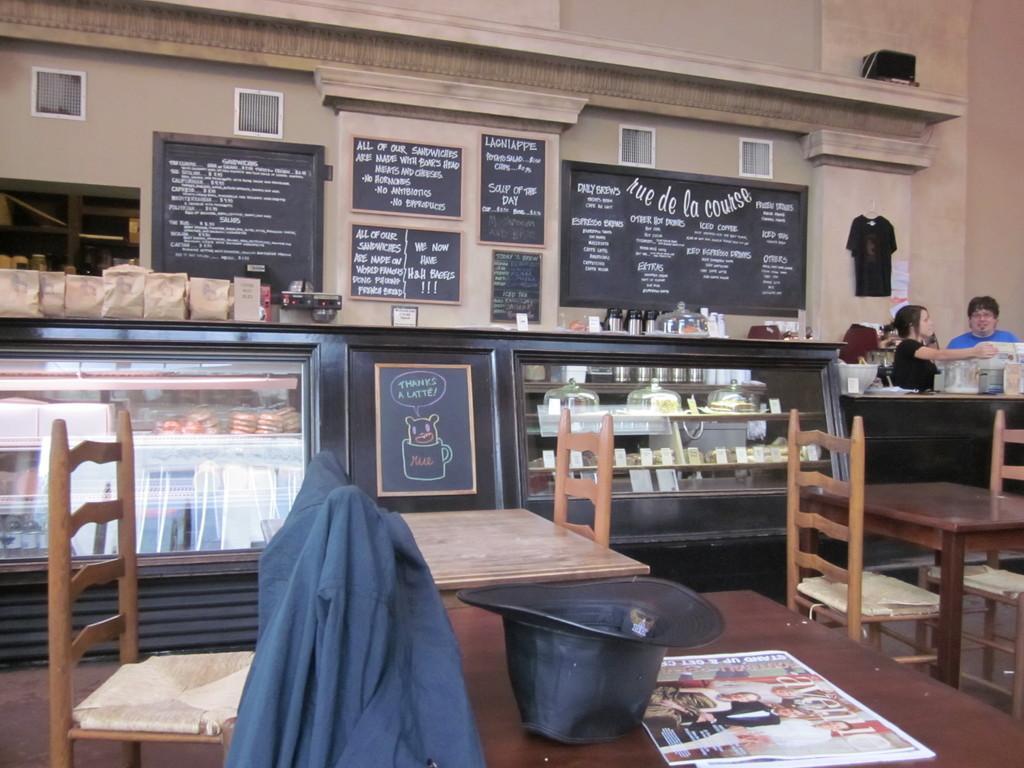In one or two sentences, can you explain what this image depicts? In this image on the right side and left side there are tables and chairs on the table there is one cap and one shirt and paper is there on the background there are some boards and windows are there and on the right side there is one wall and in the middle there is one table there are some food packets and one glass door is there and on the top of the right side there is one t shirt. 